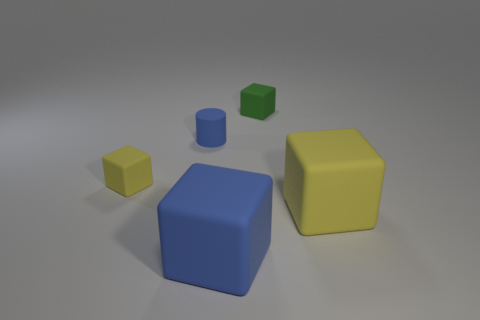What materials do the objects in the image appear to be made from? The objects in the image seem to have a matte finish, suggesting they could be made of a soft, non-reflective material such as rubber or plastic.  Which object stands out the most and why? The yellow cube stands out the most because of its vibrant color, which contrasts strongly with the more subdued colors of the other objects and the grey background. 